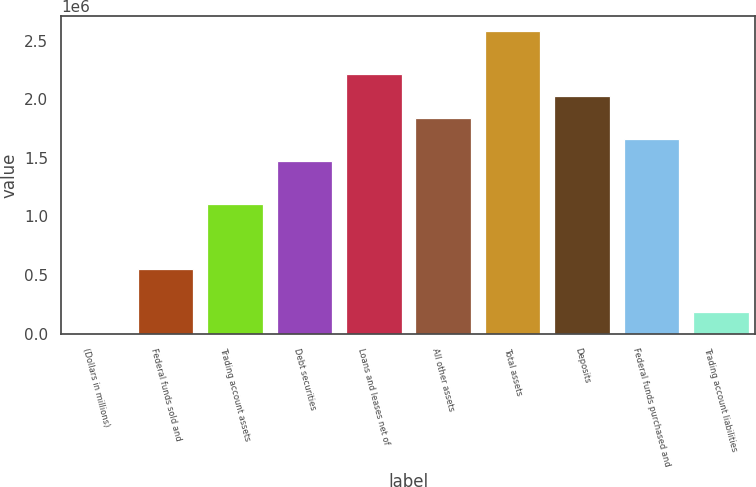Convert chart to OTSL. <chart><loc_0><loc_0><loc_500><loc_500><bar_chart><fcel>(Dollars in millions)<fcel>Federal funds sold and<fcel>Trading account assets<fcel>Debt securities<fcel>Loans and leases net of<fcel>All other assets<fcel>Total assets<fcel>Deposits<fcel>Federal funds purchased and<fcel>Trading account liabilities<nl><fcel>2008<fcel>554599<fcel>1.10719e+06<fcel>1.47558e+06<fcel>2.21237e+06<fcel>1.84398e+06<fcel>2.58077e+06<fcel>2.02818e+06<fcel>1.65978e+06<fcel>186205<nl></chart> 